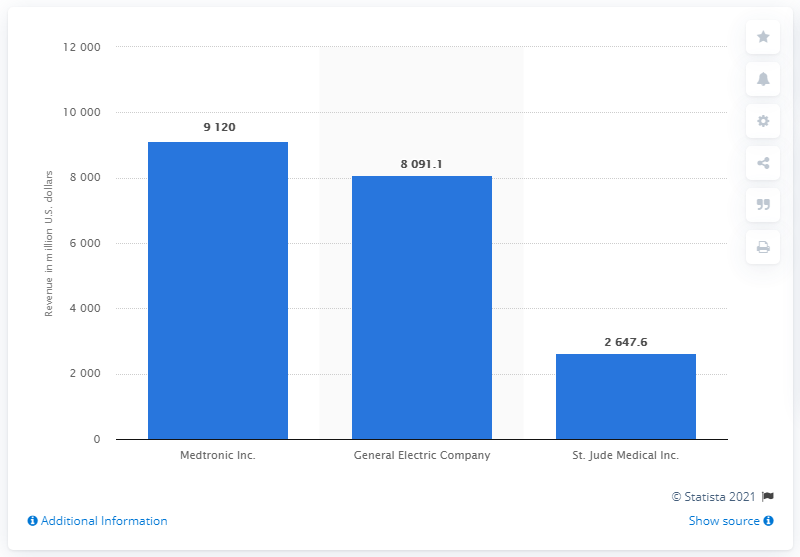Point out several critical features in this image. In 2010, St. Jude Medical Inc. generated approximately $2647.6 million in revenue. 